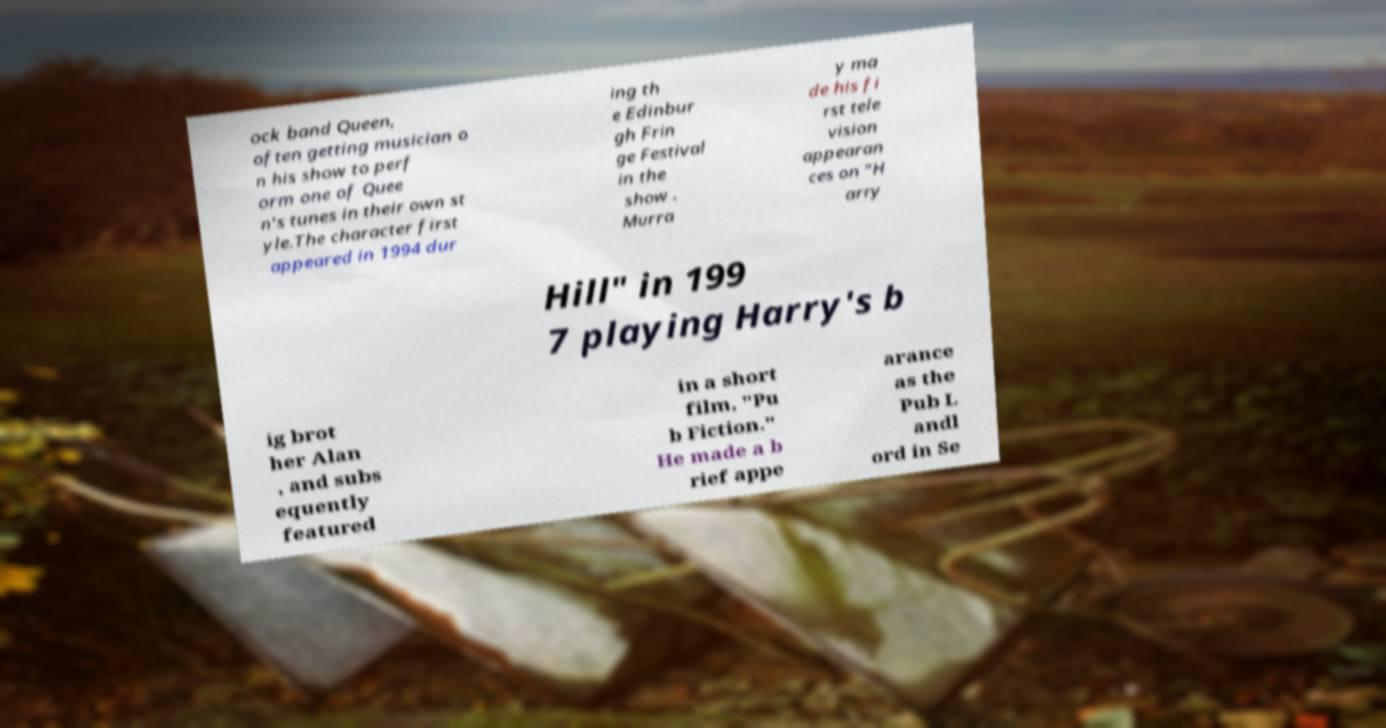I need the written content from this picture converted into text. Can you do that? ock band Queen, often getting musician o n his show to perf orm one of Quee n's tunes in their own st yle.The character first appeared in 1994 dur ing th e Edinbur gh Frin ge Festival in the show . Murra y ma de his fi rst tele vision appearan ces on "H arry Hill" in 199 7 playing Harry's b ig brot her Alan , and subs equently featured in a short film, "Pu b Fiction." He made a b rief appe arance as the Pub L andl ord in Se 